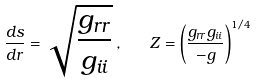Convert formula to latex. <formula><loc_0><loc_0><loc_500><loc_500>\frac { d s } { d r } = \sqrt { \frac { g _ { r r } } { g _ { i i } } } \, , \quad Z = \left ( \frac { g _ { r r } g _ { i i } } { - g } \right ) ^ { 1 / 4 }</formula> 